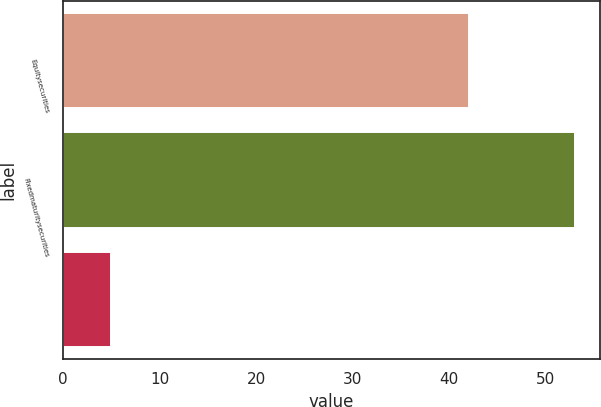<chart> <loc_0><loc_0><loc_500><loc_500><bar_chart><fcel>Equitysecurities<fcel>Fixedmaturitysecurities<fcel>Unnamed: 2<nl><fcel>42<fcel>53<fcel>5<nl></chart> 